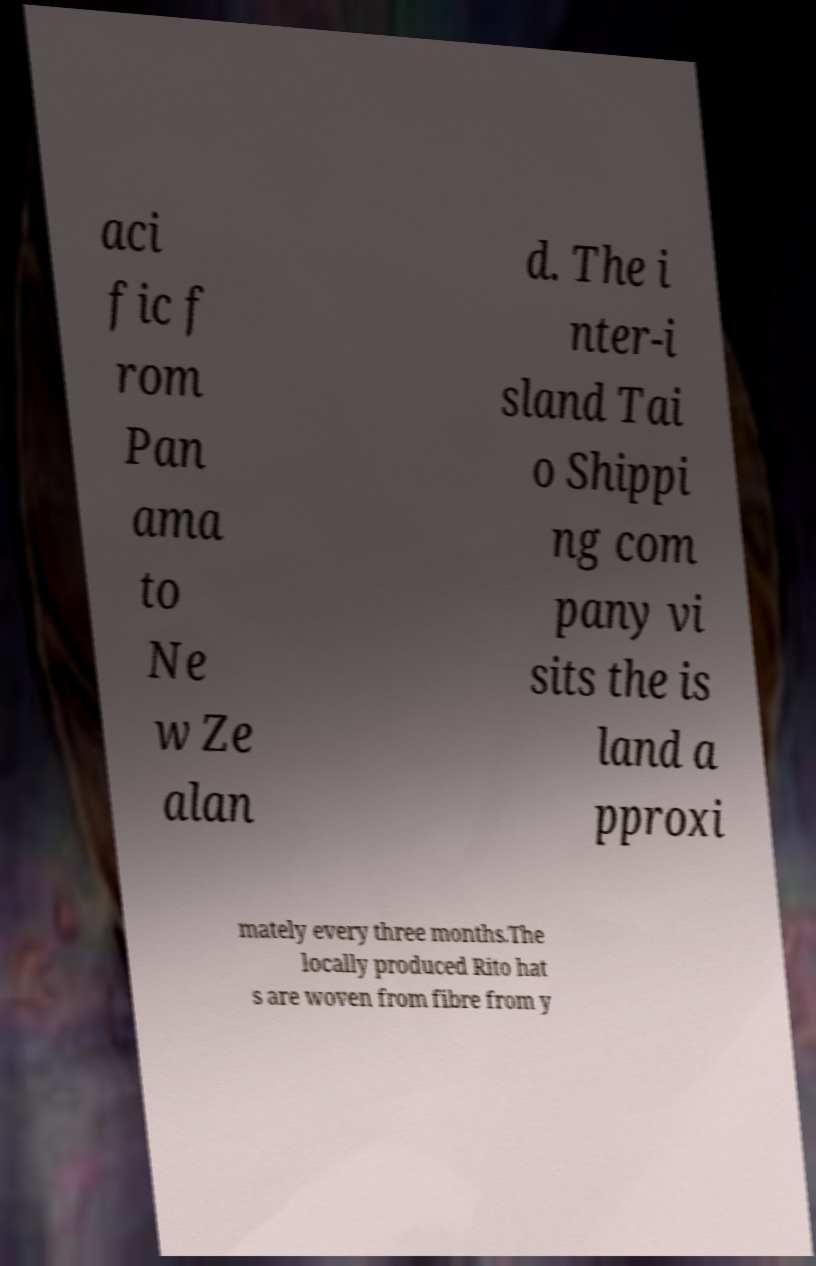For documentation purposes, I need the text within this image transcribed. Could you provide that? aci fic f rom Pan ama to Ne w Ze alan d. The i nter-i sland Tai o Shippi ng com pany vi sits the is land a pproxi mately every three months.The locally produced Rito hat s are woven from fibre from y 